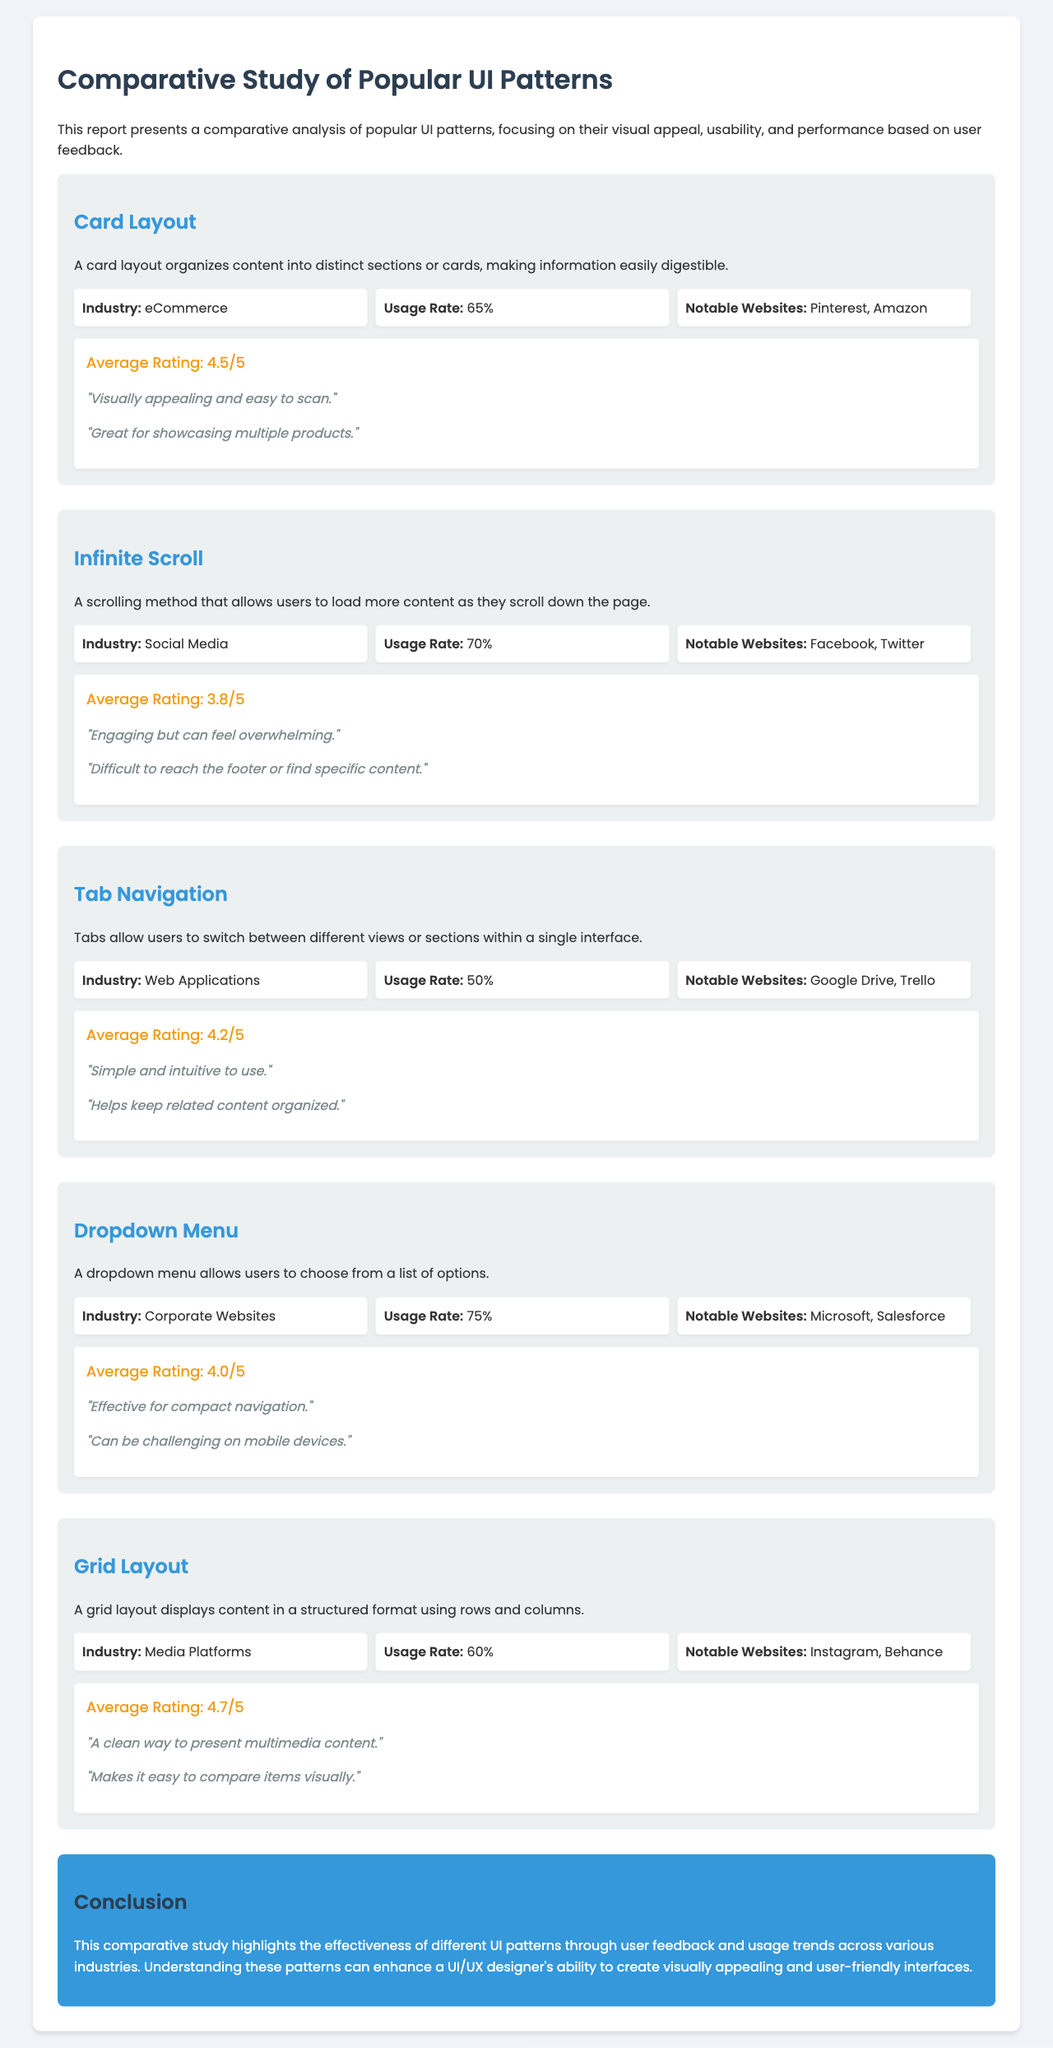What is the average rating for the Card Layout? The average rating for the Card Layout is mentioned directly in the feedback section.
Answer: 4.5/5 Which industry primarily uses the Dropdown Menu? The industry for the Dropdown Menu is stated in the statistics of the corresponding UI pattern.
Answer: Corporate Websites What is the usage rate of the Infinite Scroll pattern? The usage rate is provided in the statistics for the Infinite Scroll UI pattern.
Answer: 70% Name one notable website that uses the Grid Layout. Notable websites are listed in the statistics for the Grid Layout.
Answer: Instagram Which UI pattern has the highest average rating? To determine this, compare the average ratings listed for each pattern.
Answer: Grid Layout How do users describe the Infinite Scroll pattern? User feedback for the Infinite Scroll pattern provides insights into user perceptions.
Answer: "Engaging but can feel overwhelming." What is the conclusion regarding UI patterns? The conclusion summarizes the findings of the study based on user feedback and usage trends.
Answer: Effectiveness of different UI patterns What is the average rating for Tab Navigation? The average rating is part of the feedback in the Tab Navigation section.
Answer: 4.2/5 How many UI patterns are analyzed in this report? The number of UI patterns can be counted from the sections presented in the report.
Answer: Five 